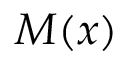Convert formula to latex. <formula><loc_0><loc_0><loc_500><loc_500>M ( x )</formula> 